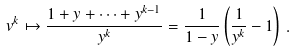<formula> <loc_0><loc_0><loc_500><loc_500>v ^ { k } \mapsto \frac { 1 + y + \dots + y ^ { k - 1 } } { y ^ { k } } = \frac { 1 } { 1 - y } \left ( \frac { 1 } { y ^ { k } } - 1 \right ) \, .</formula> 